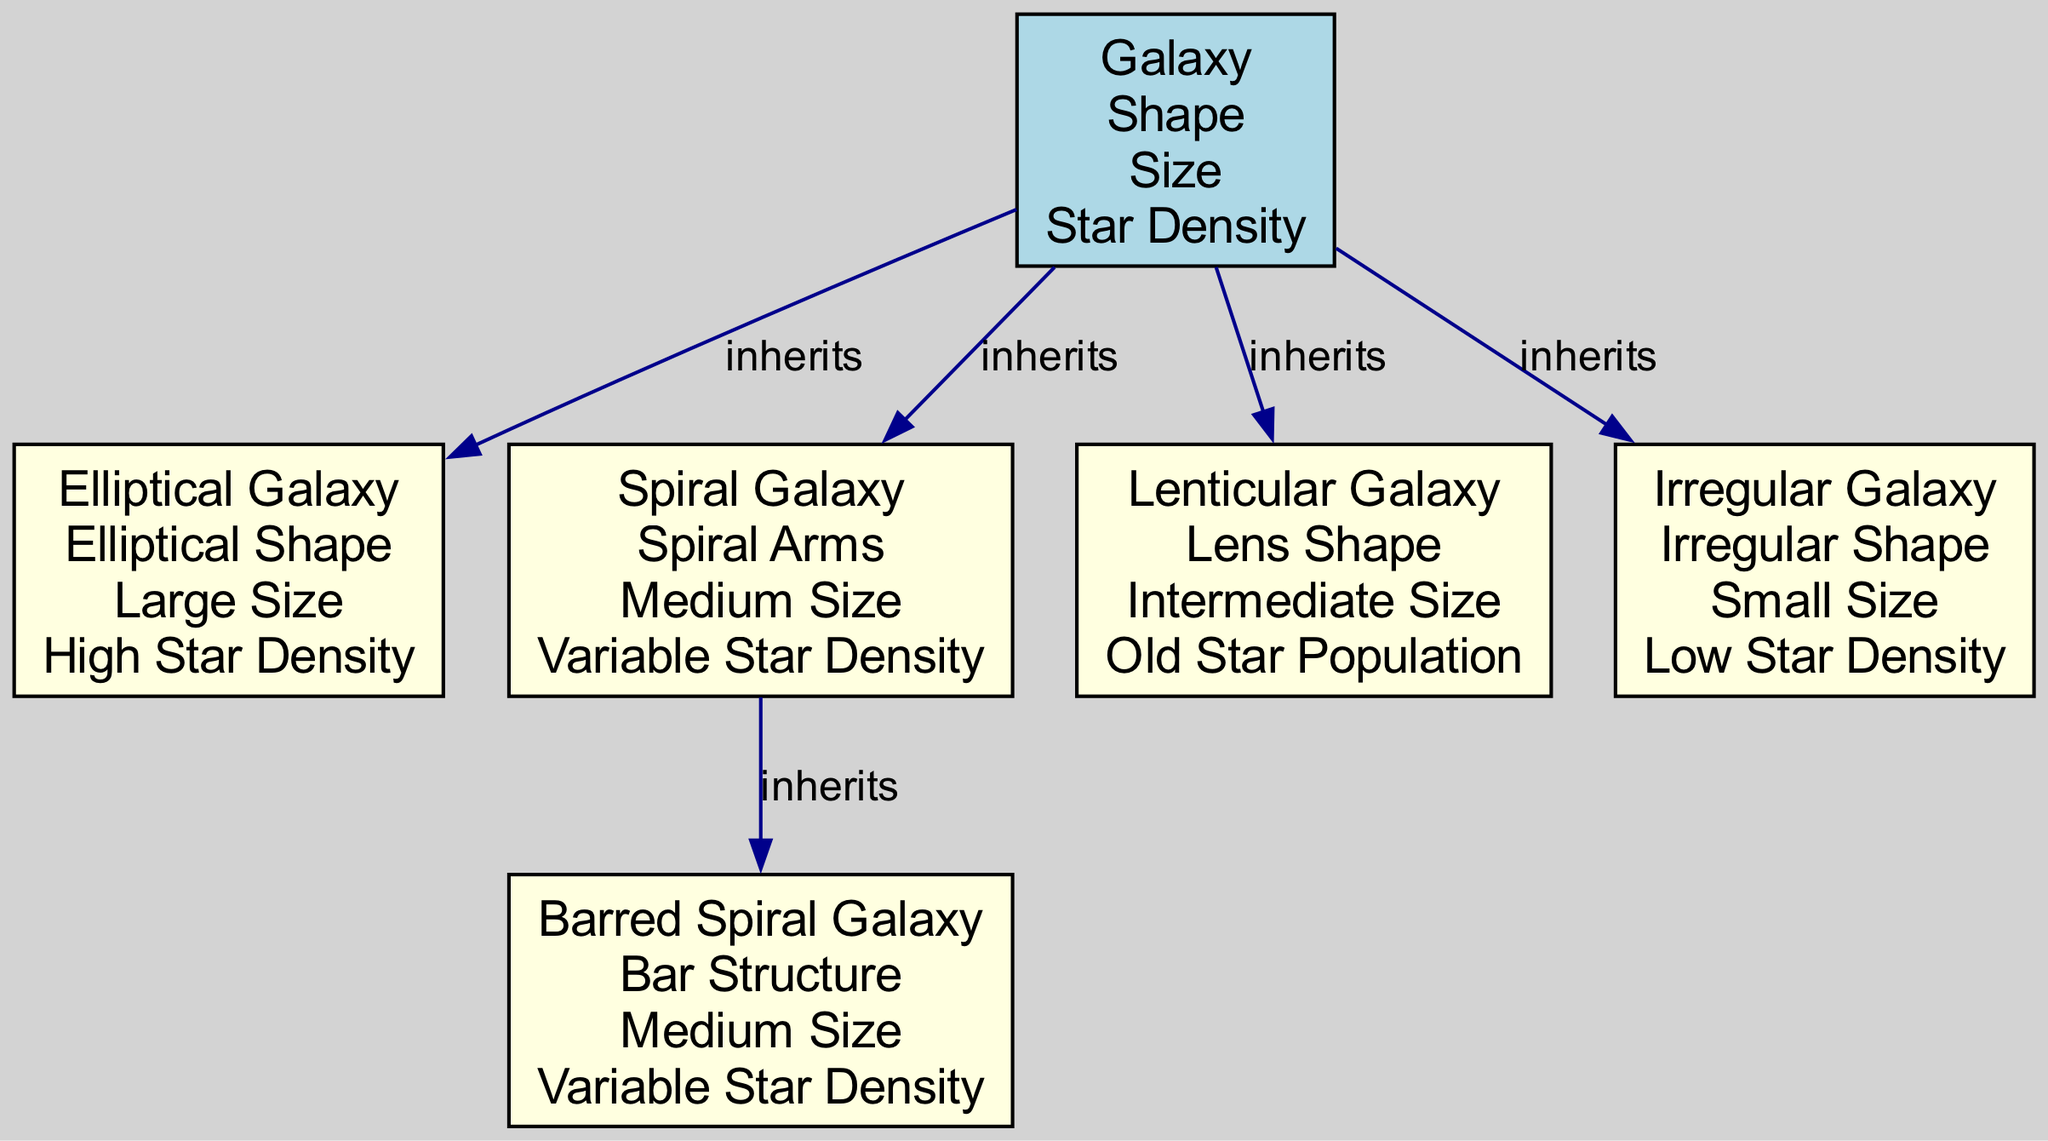What is the root classification of all galaxies in the diagram? The root classification is represented by the "Galaxy" node, which all other nodes inherit from. This node is the parent for all types of galaxies listed in the diagram.
Answer: Galaxy How many types of galaxies are categorized in this diagram? Counting the listed nodes, there are five distinct types of galaxies: Elliptical Galaxy, Spiral Galaxy, Lenticular Galaxy, Irregular Galaxy, and Barred Spiral Galaxy.
Answer: Five What attributes are shared by the elliptical galaxy? The attributes listed under the "Elliptical Galaxy" node are "Elliptical Shape," "Large Size," and "High Star Density." These attributes are specific to elliptical galaxies and inherited from the broader "Galaxy" category.
Answer: Elliptical Shape, Large Size, High Star Density Which galaxy inherits from the spiral galaxy? The "Barred Spiral Galaxy" inherits from the "Spiral Galaxy." This demonstrates a subclassification where the Barred Spiral Galaxy has characteristics of Spiral Galaxies but includes additional features.
Answer: Barred Spiral Galaxy What is the star density attribute of the irregular galaxy? The "Irregular Galaxy" has the attribute "Low Star Density," which distinguishes it from other galaxies in the diagram that have different star density levels.
Answer: Low Star Density How does the size of the lenticular galaxy compare to the elliptical galaxy? The "Lenticular Galaxy" is described as having "Intermediate Size," while the "Elliptical Galaxy" has a "Large Size." Thus, the size of a lenticular galaxy is smaller than that of an elliptical galaxy.
Answer: Intermediate Size Which type of galaxy has variable star density? Both "Spiral Galaxy" and "Barred Spiral Galaxy" are noted as having "Variable Star Density." This indicates that these galaxy types can have fluctuations in star density compared to others.
Answer: Spiral Galaxy, Barred Spiral Galaxy What shape does the lenticular galaxy possess? The "Lenticular Galaxy" is noted to possess a "Lens Shape," indicating its a defining characteristic that differentiates it from other galaxy types listed.
Answer: Lens Shape 